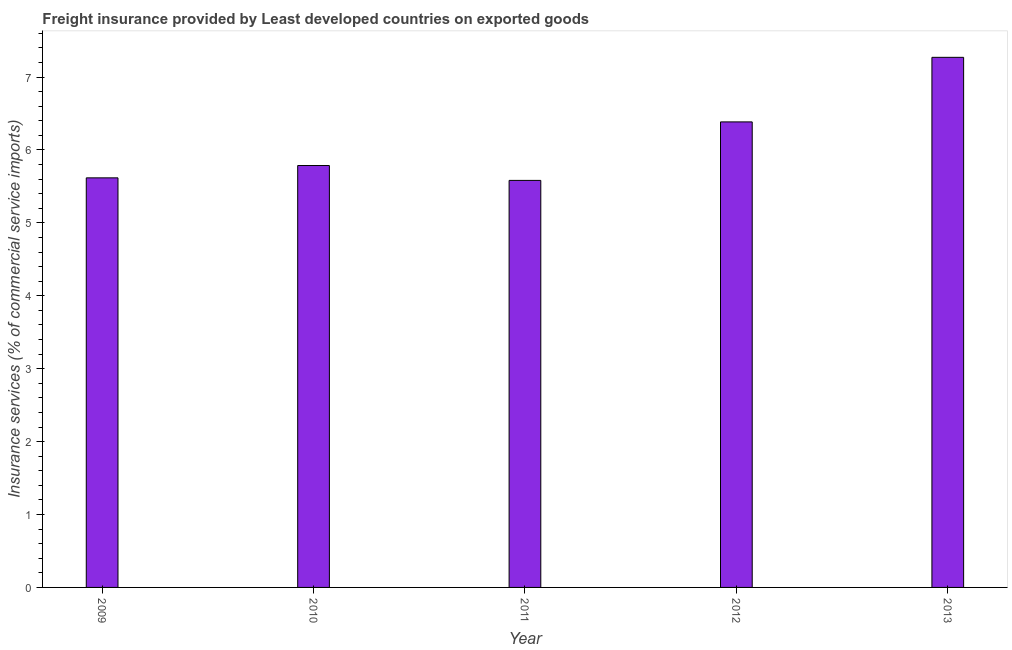What is the title of the graph?
Offer a very short reply. Freight insurance provided by Least developed countries on exported goods . What is the label or title of the X-axis?
Give a very brief answer. Year. What is the label or title of the Y-axis?
Keep it short and to the point. Insurance services (% of commercial service imports). What is the freight insurance in 2010?
Provide a short and direct response. 5.79. Across all years, what is the maximum freight insurance?
Offer a terse response. 7.27. Across all years, what is the minimum freight insurance?
Your response must be concise. 5.58. In which year was the freight insurance minimum?
Give a very brief answer. 2011. What is the sum of the freight insurance?
Make the answer very short. 30.64. What is the difference between the freight insurance in 2009 and 2010?
Ensure brevity in your answer.  -0.17. What is the average freight insurance per year?
Your response must be concise. 6.13. What is the median freight insurance?
Provide a succinct answer. 5.79. Do a majority of the years between 2010 and 2012 (inclusive) have freight insurance greater than 2 %?
Offer a very short reply. Yes. What is the ratio of the freight insurance in 2010 to that in 2013?
Provide a short and direct response. 0.8. Is the freight insurance in 2009 less than that in 2012?
Your answer should be compact. Yes. Is the difference between the freight insurance in 2009 and 2013 greater than the difference between any two years?
Keep it short and to the point. No. What is the difference between the highest and the second highest freight insurance?
Your response must be concise. 0.89. Is the sum of the freight insurance in 2011 and 2012 greater than the maximum freight insurance across all years?
Offer a terse response. Yes. What is the difference between the highest and the lowest freight insurance?
Offer a terse response. 1.69. Are all the bars in the graph horizontal?
Your answer should be very brief. No. How many years are there in the graph?
Your answer should be very brief. 5. What is the difference between two consecutive major ticks on the Y-axis?
Your answer should be compact. 1. Are the values on the major ticks of Y-axis written in scientific E-notation?
Offer a very short reply. No. What is the Insurance services (% of commercial service imports) of 2009?
Keep it short and to the point. 5.62. What is the Insurance services (% of commercial service imports) in 2010?
Provide a short and direct response. 5.79. What is the Insurance services (% of commercial service imports) in 2011?
Offer a very short reply. 5.58. What is the Insurance services (% of commercial service imports) in 2012?
Provide a succinct answer. 6.39. What is the Insurance services (% of commercial service imports) in 2013?
Ensure brevity in your answer.  7.27. What is the difference between the Insurance services (% of commercial service imports) in 2009 and 2010?
Ensure brevity in your answer.  -0.17. What is the difference between the Insurance services (% of commercial service imports) in 2009 and 2011?
Keep it short and to the point. 0.03. What is the difference between the Insurance services (% of commercial service imports) in 2009 and 2012?
Your response must be concise. -0.77. What is the difference between the Insurance services (% of commercial service imports) in 2009 and 2013?
Give a very brief answer. -1.65. What is the difference between the Insurance services (% of commercial service imports) in 2010 and 2011?
Ensure brevity in your answer.  0.2. What is the difference between the Insurance services (% of commercial service imports) in 2010 and 2012?
Provide a short and direct response. -0.6. What is the difference between the Insurance services (% of commercial service imports) in 2010 and 2013?
Provide a short and direct response. -1.48. What is the difference between the Insurance services (% of commercial service imports) in 2011 and 2012?
Offer a very short reply. -0.8. What is the difference between the Insurance services (% of commercial service imports) in 2011 and 2013?
Your response must be concise. -1.69. What is the difference between the Insurance services (% of commercial service imports) in 2012 and 2013?
Ensure brevity in your answer.  -0.89. What is the ratio of the Insurance services (% of commercial service imports) in 2009 to that in 2010?
Offer a very short reply. 0.97. What is the ratio of the Insurance services (% of commercial service imports) in 2009 to that in 2012?
Your answer should be compact. 0.88. What is the ratio of the Insurance services (% of commercial service imports) in 2009 to that in 2013?
Give a very brief answer. 0.77. What is the ratio of the Insurance services (% of commercial service imports) in 2010 to that in 2012?
Your response must be concise. 0.91. What is the ratio of the Insurance services (% of commercial service imports) in 2010 to that in 2013?
Offer a very short reply. 0.8. What is the ratio of the Insurance services (% of commercial service imports) in 2011 to that in 2012?
Offer a terse response. 0.87. What is the ratio of the Insurance services (% of commercial service imports) in 2011 to that in 2013?
Make the answer very short. 0.77. What is the ratio of the Insurance services (% of commercial service imports) in 2012 to that in 2013?
Provide a succinct answer. 0.88. 